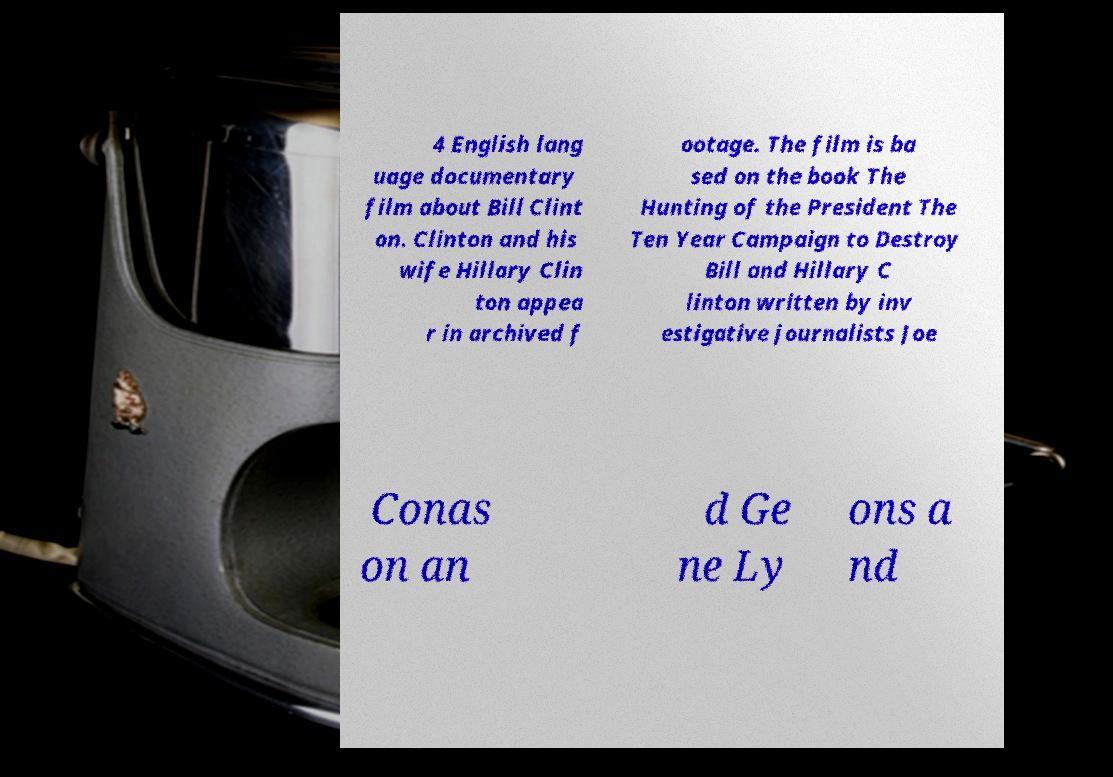Could you extract and type out the text from this image? 4 English lang uage documentary film about Bill Clint on. Clinton and his wife Hillary Clin ton appea r in archived f ootage. The film is ba sed on the book The Hunting of the President The Ten Year Campaign to Destroy Bill and Hillary C linton written by inv estigative journalists Joe Conas on an d Ge ne Ly ons a nd 